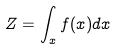Convert formula to latex. <formula><loc_0><loc_0><loc_500><loc_500>Z = \int _ { x } f ( x ) d x</formula> 